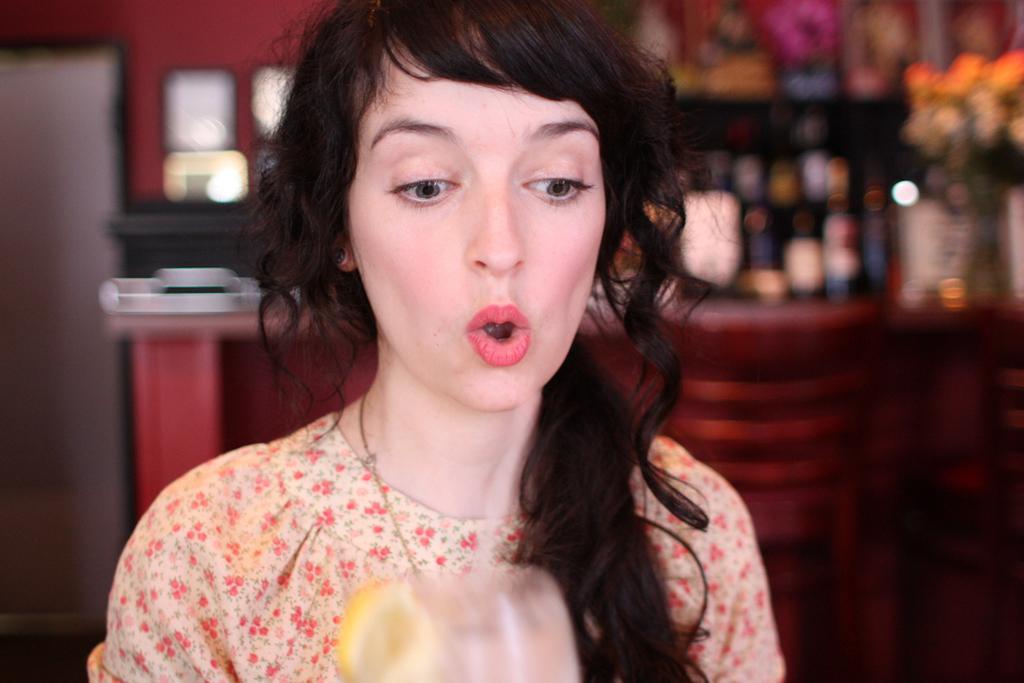How would you summarize this image in a sentence or two? In this picture we can see a woman and we can find blurry background. 